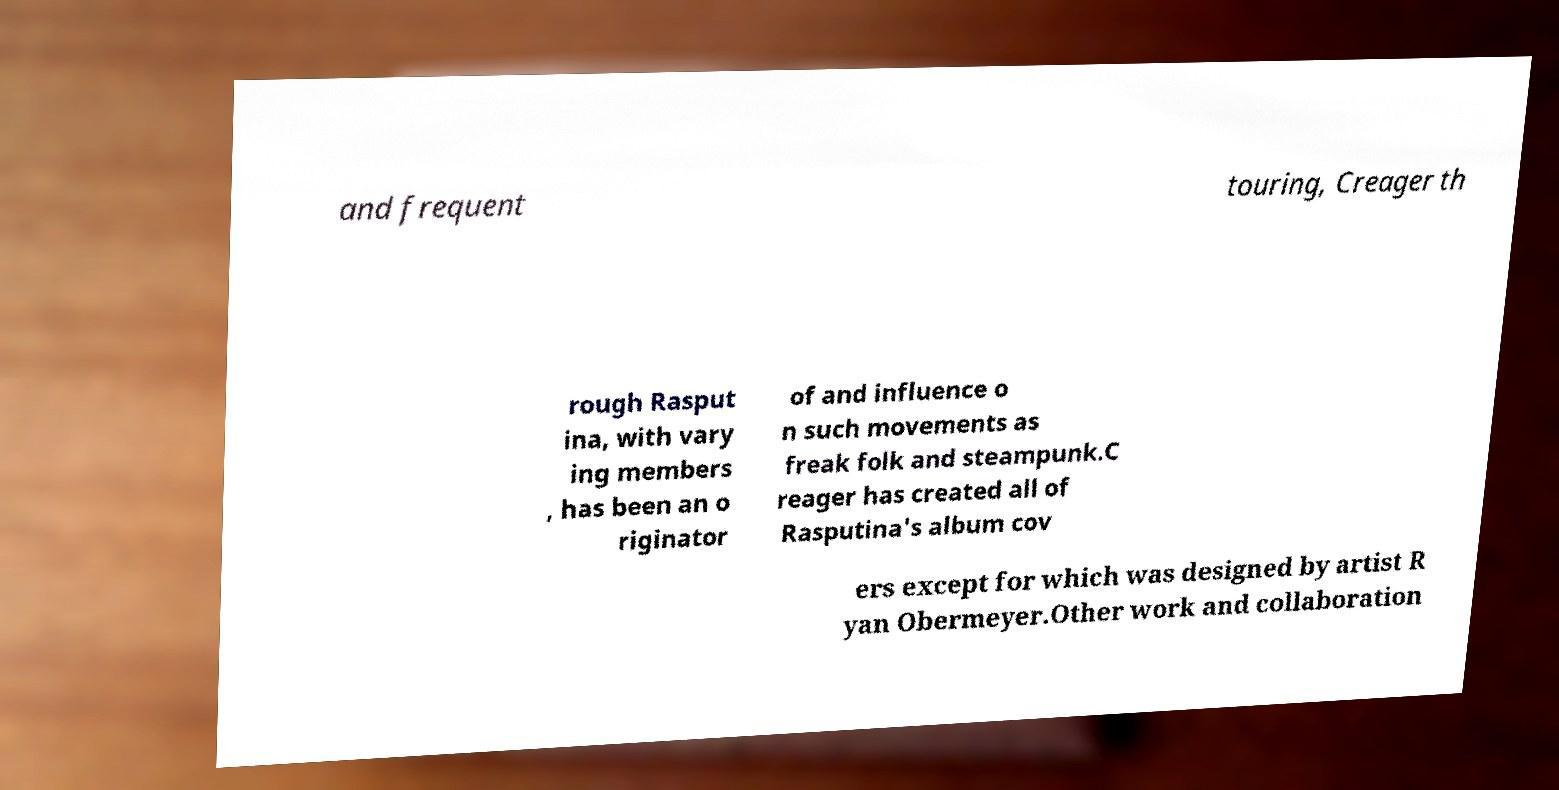Please identify and transcribe the text found in this image. and frequent touring, Creager th rough Rasput ina, with vary ing members , has been an o riginator of and influence o n such movements as freak folk and steampunk.C reager has created all of Rasputina's album cov ers except for which was designed by artist R yan Obermeyer.Other work and collaboration 